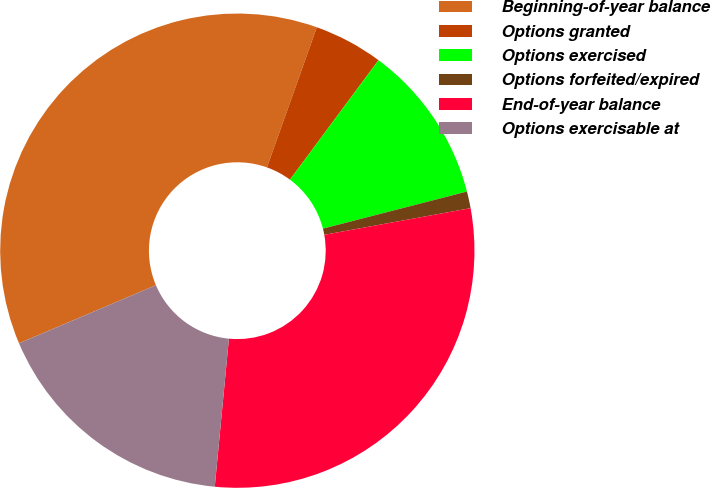<chart> <loc_0><loc_0><loc_500><loc_500><pie_chart><fcel>Beginning-of-year balance<fcel>Options granted<fcel>Options exercised<fcel>Options forfeited/expired<fcel>End-of-year balance<fcel>Options exercisable at<nl><fcel>36.83%<fcel>4.71%<fcel>10.84%<fcel>1.14%<fcel>29.39%<fcel>17.1%<nl></chart> 